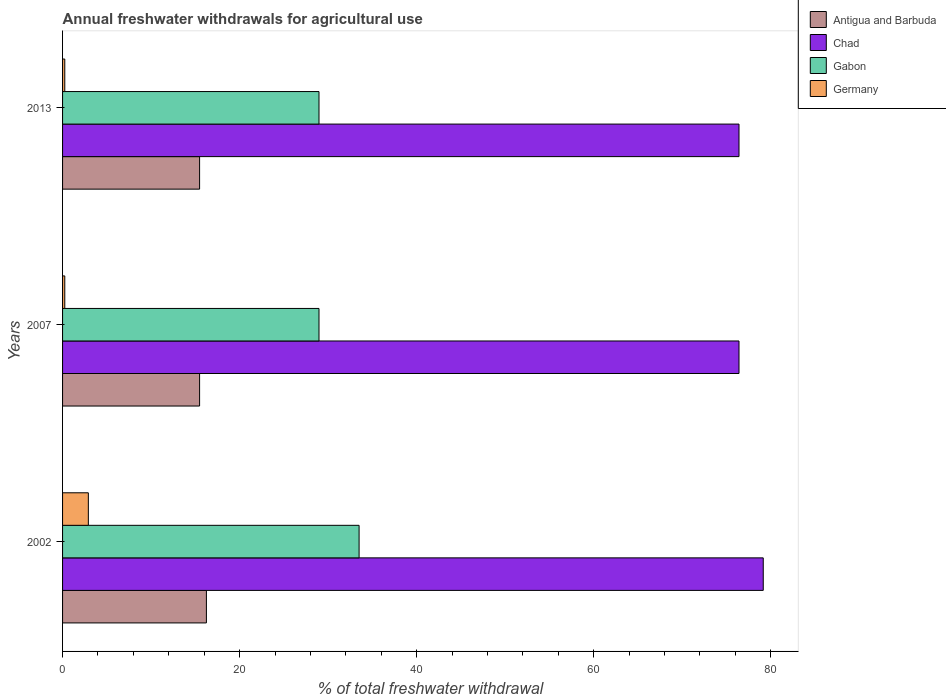How many groups of bars are there?
Offer a terse response. 3. Are the number of bars per tick equal to the number of legend labels?
Ensure brevity in your answer.  Yes. What is the label of the 2nd group of bars from the top?
Make the answer very short. 2007. In how many cases, is the number of bars for a given year not equal to the number of legend labels?
Give a very brief answer. 0. What is the total annual withdrawals from freshwater in Gabon in 2013?
Your response must be concise. 28.97. Across all years, what is the maximum total annual withdrawals from freshwater in Chad?
Give a very brief answer. 79.16. Across all years, what is the minimum total annual withdrawals from freshwater in Germany?
Your response must be concise. 0.25. In which year was the total annual withdrawals from freshwater in Chad maximum?
Keep it short and to the point. 2002. In which year was the total annual withdrawals from freshwater in Chad minimum?
Your answer should be compact. 2007. What is the total total annual withdrawals from freshwater in Gabon in the graph?
Your answer should be very brief. 91.44. What is the difference between the total annual withdrawals from freshwater in Chad in 2007 and the total annual withdrawals from freshwater in Gabon in 2013?
Keep it short and to the point. 47.45. What is the average total annual withdrawals from freshwater in Chad per year?
Your answer should be very brief. 77.33. In the year 2007, what is the difference between the total annual withdrawals from freshwater in Antigua and Barbuda and total annual withdrawals from freshwater in Gabon?
Provide a succinct answer. -13.49. What is the ratio of the total annual withdrawals from freshwater in Antigua and Barbuda in 2002 to that in 2013?
Your response must be concise. 1.05. Is the total annual withdrawals from freshwater in Chad in 2007 less than that in 2013?
Keep it short and to the point. No. What is the difference between the highest and the second highest total annual withdrawals from freshwater in Gabon?
Keep it short and to the point. 4.53. What is the difference between the highest and the lowest total annual withdrawals from freshwater in Germany?
Offer a very short reply. 2.66. Is the sum of the total annual withdrawals from freshwater in Chad in 2002 and 2013 greater than the maximum total annual withdrawals from freshwater in Antigua and Barbuda across all years?
Offer a terse response. Yes. Is it the case that in every year, the sum of the total annual withdrawals from freshwater in Gabon and total annual withdrawals from freshwater in Germany is greater than the sum of total annual withdrawals from freshwater in Antigua and Barbuda and total annual withdrawals from freshwater in Chad?
Ensure brevity in your answer.  No. What does the 4th bar from the top in 2013 represents?
Ensure brevity in your answer.  Antigua and Barbuda. What does the 3rd bar from the bottom in 2002 represents?
Ensure brevity in your answer.  Gabon. Are all the bars in the graph horizontal?
Offer a very short reply. Yes. What is the difference between two consecutive major ticks on the X-axis?
Your response must be concise. 20. Does the graph contain any zero values?
Provide a short and direct response. No. Where does the legend appear in the graph?
Provide a short and direct response. Top right. How many legend labels are there?
Provide a succinct answer. 4. What is the title of the graph?
Provide a short and direct response. Annual freshwater withdrawals for agricultural use. What is the label or title of the X-axis?
Your answer should be compact. % of total freshwater withdrawal. What is the % of total freshwater withdrawal in Antigua and Barbuda in 2002?
Offer a very short reply. 16.25. What is the % of total freshwater withdrawal in Chad in 2002?
Your answer should be compact. 79.16. What is the % of total freshwater withdrawal in Gabon in 2002?
Provide a short and direct response. 33.5. What is the % of total freshwater withdrawal of Germany in 2002?
Make the answer very short. 2.91. What is the % of total freshwater withdrawal of Antigua and Barbuda in 2007?
Your response must be concise. 15.48. What is the % of total freshwater withdrawal in Chad in 2007?
Keep it short and to the point. 76.42. What is the % of total freshwater withdrawal in Gabon in 2007?
Offer a terse response. 28.97. What is the % of total freshwater withdrawal in Germany in 2007?
Provide a succinct answer. 0.25. What is the % of total freshwater withdrawal in Antigua and Barbuda in 2013?
Provide a short and direct response. 15.48. What is the % of total freshwater withdrawal in Chad in 2013?
Keep it short and to the point. 76.42. What is the % of total freshwater withdrawal of Gabon in 2013?
Ensure brevity in your answer.  28.97. What is the % of total freshwater withdrawal in Germany in 2013?
Ensure brevity in your answer.  0.25. Across all years, what is the maximum % of total freshwater withdrawal of Antigua and Barbuda?
Provide a short and direct response. 16.25. Across all years, what is the maximum % of total freshwater withdrawal in Chad?
Offer a terse response. 79.16. Across all years, what is the maximum % of total freshwater withdrawal in Gabon?
Provide a succinct answer. 33.5. Across all years, what is the maximum % of total freshwater withdrawal in Germany?
Ensure brevity in your answer.  2.91. Across all years, what is the minimum % of total freshwater withdrawal of Antigua and Barbuda?
Make the answer very short. 15.48. Across all years, what is the minimum % of total freshwater withdrawal of Chad?
Your answer should be very brief. 76.42. Across all years, what is the minimum % of total freshwater withdrawal of Gabon?
Offer a terse response. 28.97. Across all years, what is the minimum % of total freshwater withdrawal of Germany?
Your response must be concise. 0.25. What is the total % of total freshwater withdrawal of Antigua and Barbuda in the graph?
Keep it short and to the point. 47.21. What is the total % of total freshwater withdrawal of Chad in the graph?
Give a very brief answer. 232. What is the total % of total freshwater withdrawal in Gabon in the graph?
Give a very brief answer. 91.44. What is the total % of total freshwater withdrawal in Germany in the graph?
Ensure brevity in your answer.  3.41. What is the difference between the % of total freshwater withdrawal in Antigua and Barbuda in 2002 and that in 2007?
Make the answer very short. 0.77. What is the difference between the % of total freshwater withdrawal of Chad in 2002 and that in 2007?
Provide a succinct answer. 2.74. What is the difference between the % of total freshwater withdrawal of Gabon in 2002 and that in 2007?
Offer a terse response. 4.53. What is the difference between the % of total freshwater withdrawal in Germany in 2002 and that in 2007?
Give a very brief answer. 2.66. What is the difference between the % of total freshwater withdrawal in Antigua and Barbuda in 2002 and that in 2013?
Give a very brief answer. 0.77. What is the difference between the % of total freshwater withdrawal in Chad in 2002 and that in 2013?
Provide a short and direct response. 2.74. What is the difference between the % of total freshwater withdrawal of Gabon in 2002 and that in 2013?
Your response must be concise. 4.53. What is the difference between the % of total freshwater withdrawal in Germany in 2002 and that in 2013?
Make the answer very short. 2.66. What is the difference between the % of total freshwater withdrawal in Chad in 2007 and that in 2013?
Your answer should be compact. 0. What is the difference between the % of total freshwater withdrawal of Gabon in 2007 and that in 2013?
Offer a terse response. 0. What is the difference between the % of total freshwater withdrawal of Germany in 2007 and that in 2013?
Your answer should be very brief. 0. What is the difference between the % of total freshwater withdrawal in Antigua and Barbuda in 2002 and the % of total freshwater withdrawal in Chad in 2007?
Offer a very short reply. -60.17. What is the difference between the % of total freshwater withdrawal of Antigua and Barbuda in 2002 and the % of total freshwater withdrawal of Gabon in 2007?
Offer a very short reply. -12.72. What is the difference between the % of total freshwater withdrawal of Antigua and Barbuda in 2002 and the % of total freshwater withdrawal of Germany in 2007?
Your answer should be compact. 16. What is the difference between the % of total freshwater withdrawal in Chad in 2002 and the % of total freshwater withdrawal in Gabon in 2007?
Keep it short and to the point. 50.19. What is the difference between the % of total freshwater withdrawal in Chad in 2002 and the % of total freshwater withdrawal in Germany in 2007?
Offer a terse response. 78.91. What is the difference between the % of total freshwater withdrawal in Gabon in 2002 and the % of total freshwater withdrawal in Germany in 2007?
Your answer should be compact. 33.25. What is the difference between the % of total freshwater withdrawal of Antigua and Barbuda in 2002 and the % of total freshwater withdrawal of Chad in 2013?
Your answer should be very brief. -60.17. What is the difference between the % of total freshwater withdrawal of Antigua and Barbuda in 2002 and the % of total freshwater withdrawal of Gabon in 2013?
Offer a terse response. -12.72. What is the difference between the % of total freshwater withdrawal of Antigua and Barbuda in 2002 and the % of total freshwater withdrawal of Germany in 2013?
Provide a succinct answer. 16. What is the difference between the % of total freshwater withdrawal in Chad in 2002 and the % of total freshwater withdrawal in Gabon in 2013?
Ensure brevity in your answer.  50.19. What is the difference between the % of total freshwater withdrawal in Chad in 2002 and the % of total freshwater withdrawal in Germany in 2013?
Provide a short and direct response. 78.91. What is the difference between the % of total freshwater withdrawal of Gabon in 2002 and the % of total freshwater withdrawal of Germany in 2013?
Offer a terse response. 33.25. What is the difference between the % of total freshwater withdrawal in Antigua and Barbuda in 2007 and the % of total freshwater withdrawal in Chad in 2013?
Offer a terse response. -60.94. What is the difference between the % of total freshwater withdrawal in Antigua and Barbuda in 2007 and the % of total freshwater withdrawal in Gabon in 2013?
Keep it short and to the point. -13.49. What is the difference between the % of total freshwater withdrawal in Antigua and Barbuda in 2007 and the % of total freshwater withdrawal in Germany in 2013?
Give a very brief answer. 15.23. What is the difference between the % of total freshwater withdrawal in Chad in 2007 and the % of total freshwater withdrawal in Gabon in 2013?
Provide a succinct answer. 47.45. What is the difference between the % of total freshwater withdrawal in Chad in 2007 and the % of total freshwater withdrawal in Germany in 2013?
Your response must be concise. 76.17. What is the difference between the % of total freshwater withdrawal in Gabon in 2007 and the % of total freshwater withdrawal in Germany in 2013?
Provide a succinct answer. 28.72. What is the average % of total freshwater withdrawal of Antigua and Barbuda per year?
Offer a very short reply. 15.74. What is the average % of total freshwater withdrawal of Chad per year?
Provide a succinct answer. 77.33. What is the average % of total freshwater withdrawal of Gabon per year?
Provide a succinct answer. 30.48. What is the average % of total freshwater withdrawal in Germany per year?
Give a very brief answer. 1.14. In the year 2002, what is the difference between the % of total freshwater withdrawal of Antigua and Barbuda and % of total freshwater withdrawal of Chad?
Your answer should be compact. -62.91. In the year 2002, what is the difference between the % of total freshwater withdrawal of Antigua and Barbuda and % of total freshwater withdrawal of Gabon?
Your answer should be compact. -17.25. In the year 2002, what is the difference between the % of total freshwater withdrawal of Antigua and Barbuda and % of total freshwater withdrawal of Germany?
Provide a short and direct response. 13.34. In the year 2002, what is the difference between the % of total freshwater withdrawal in Chad and % of total freshwater withdrawal in Gabon?
Your answer should be compact. 45.66. In the year 2002, what is the difference between the % of total freshwater withdrawal of Chad and % of total freshwater withdrawal of Germany?
Provide a succinct answer. 76.25. In the year 2002, what is the difference between the % of total freshwater withdrawal in Gabon and % of total freshwater withdrawal in Germany?
Your answer should be very brief. 30.59. In the year 2007, what is the difference between the % of total freshwater withdrawal of Antigua and Barbuda and % of total freshwater withdrawal of Chad?
Keep it short and to the point. -60.94. In the year 2007, what is the difference between the % of total freshwater withdrawal in Antigua and Barbuda and % of total freshwater withdrawal in Gabon?
Offer a very short reply. -13.49. In the year 2007, what is the difference between the % of total freshwater withdrawal in Antigua and Barbuda and % of total freshwater withdrawal in Germany?
Your answer should be compact. 15.23. In the year 2007, what is the difference between the % of total freshwater withdrawal in Chad and % of total freshwater withdrawal in Gabon?
Offer a very short reply. 47.45. In the year 2007, what is the difference between the % of total freshwater withdrawal in Chad and % of total freshwater withdrawal in Germany?
Provide a short and direct response. 76.17. In the year 2007, what is the difference between the % of total freshwater withdrawal in Gabon and % of total freshwater withdrawal in Germany?
Make the answer very short. 28.72. In the year 2013, what is the difference between the % of total freshwater withdrawal in Antigua and Barbuda and % of total freshwater withdrawal in Chad?
Your response must be concise. -60.94. In the year 2013, what is the difference between the % of total freshwater withdrawal of Antigua and Barbuda and % of total freshwater withdrawal of Gabon?
Your response must be concise. -13.49. In the year 2013, what is the difference between the % of total freshwater withdrawal of Antigua and Barbuda and % of total freshwater withdrawal of Germany?
Provide a short and direct response. 15.23. In the year 2013, what is the difference between the % of total freshwater withdrawal in Chad and % of total freshwater withdrawal in Gabon?
Make the answer very short. 47.45. In the year 2013, what is the difference between the % of total freshwater withdrawal of Chad and % of total freshwater withdrawal of Germany?
Provide a short and direct response. 76.17. In the year 2013, what is the difference between the % of total freshwater withdrawal of Gabon and % of total freshwater withdrawal of Germany?
Keep it short and to the point. 28.72. What is the ratio of the % of total freshwater withdrawal in Antigua and Barbuda in 2002 to that in 2007?
Offer a terse response. 1.05. What is the ratio of the % of total freshwater withdrawal in Chad in 2002 to that in 2007?
Provide a succinct answer. 1.04. What is the ratio of the % of total freshwater withdrawal in Gabon in 2002 to that in 2007?
Your response must be concise. 1.16. What is the ratio of the % of total freshwater withdrawal in Germany in 2002 to that in 2007?
Your answer should be very brief. 11.61. What is the ratio of the % of total freshwater withdrawal in Antigua and Barbuda in 2002 to that in 2013?
Give a very brief answer. 1.05. What is the ratio of the % of total freshwater withdrawal of Chad in 2002 to that in 2013?
Your response must be concise. 1.04. What is the ratio of the % of total freshwater withdrawal of Gabon in 2002 to that in 2013?
Ensure brevity in your answer.  1.16. What is the ratio of the % of total freshwater withdrawal in Germany in 2002 to that in 2013?
Your answer should be compact. 11.61. What is the ratio of the % of total freshwater withdrawal in Chad in 2007 to that in 2013?
Offer a very short reply. 1. What is the ratio of the % of total freshwater withdrawal of Germany in 2007 to that in 2013?
Ensure brevity in your answer.  1. What is the difference between the highest and the second highest % of total freshwater withdrawal of Antigua and Barbuda?
Offer a very short reply. 0.77. What is the difference between the highest and the second highest % of total freshwater withdrawal of Chad?
Your response must be concise. 2.74. What is the difference between the highest and the second highest % of total freshwater withdrawal in Gabon?
Give a very brief answer. 4.53. What is the difference between the highest and the second highest % of total freshwater withdrawal in Germany?
Make the answer very short. 2.66. What is the difference between the highest and the lowest % of total freshwater withdrawal of Antigua and Barbuda?
Make the answer very short. 0.77. What is the difference between the highest and the lowest % of total freshwater withdrawal of Chad?
Offer a terse response. 2.74. What is the difference between the highest and the lowest % of total freshwater withdrawal of Gabon?
Keep it short and to the point. 4.53. What is the difference between the highest and the lowest % of total freshwater withdrawal in Germany?
Your answer should be very brief. 2.66. 